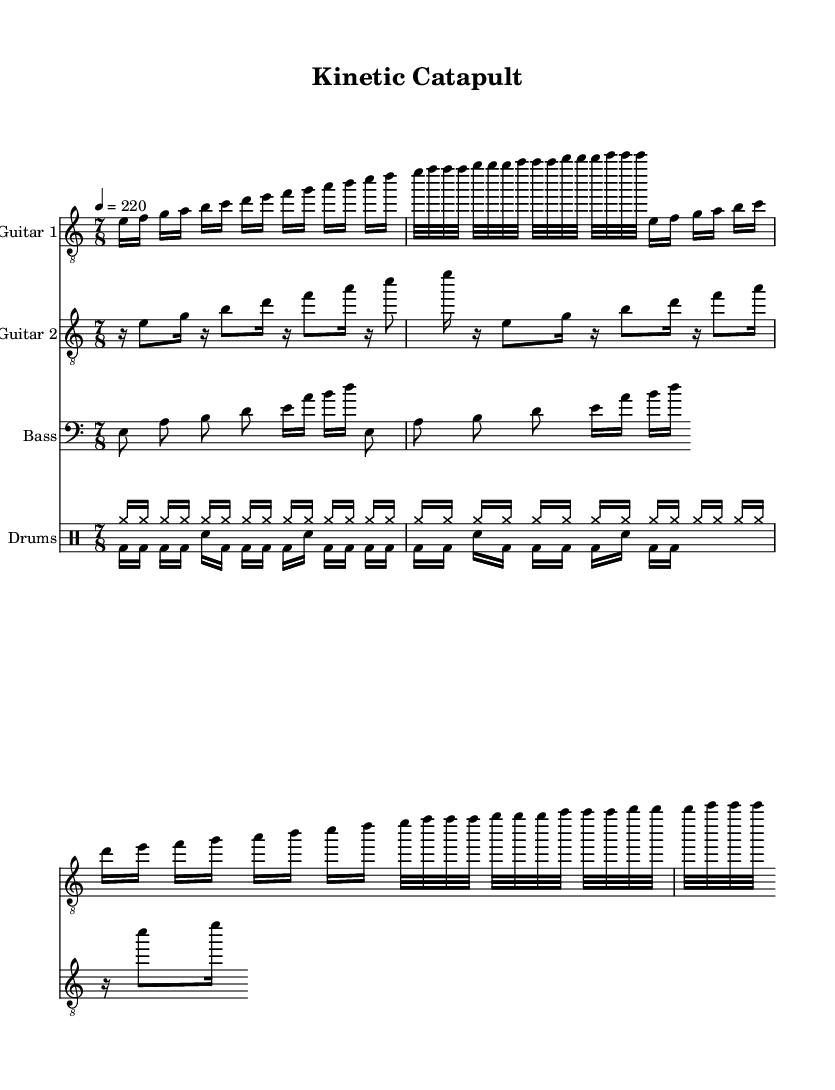What is the time signature of this music? The time signature is indicated at the beginning of the score, showing a 7/8 signature, which means there are 7 beats in a measure and the eighth note gets the beat.
Answer: 7/8 What is the key signature of this piece? The key signature is E Phrygian, which is shown at the beginning as part of the global settings, indicating the specific pitches used in this scale and composition.
Answer: E Phrygian What is the tempo marking of the composition? The tempo marking is specified in the global settings, showing that the piece should be played at a speed of 220 beats per minute, indicated as 4 = 220.
Answer: 220 How many times is the main guitar melody repeated? The guitar melody is repeated two times, as specified by the "\repeat unfold 2" command in the sheet music, indicating a duplication of the section.
Answer: 2 What rhythmic pattern do you observe in the drum section? The drum section consists of alternating cymbal hits and bass drum beats, with specific groupings and variations, showcasing a typical heavy metal rhythmic drive.
Answer: Alternating cymbals and bass drum Identify the primary instrument featured in the piece. The primary instruments are the guitars, which take the lead roles in playing the melodic lines, as indicated by the separate staves for Guitar 1 and Guitar 2.
Answer: Guitars What is the duration of the notes in the first guitar part? The first guitar part primarily consists of sixteenth and eighth notes, indicated by the different notational values in the music, which contribute to the overall technical complexity.
Answer: Sixteenth and eighth notes 